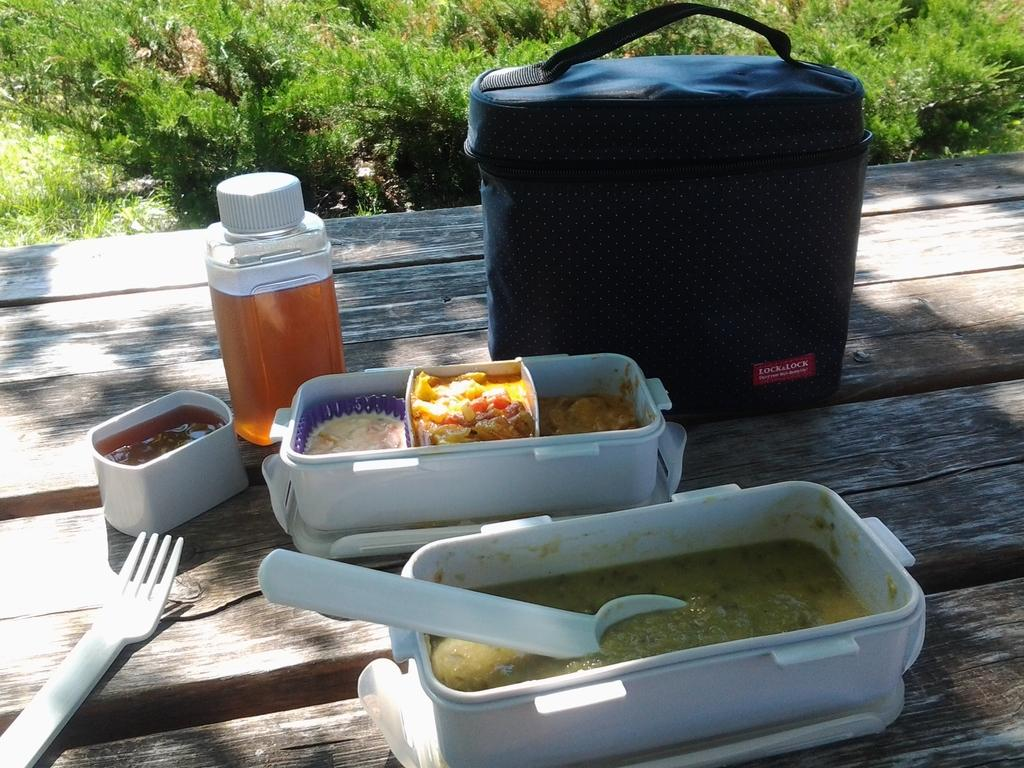<image>
Offer a succinct explanation of the picture presented. A Lock & Lock cooler sits by food and a beverage outdoors. 